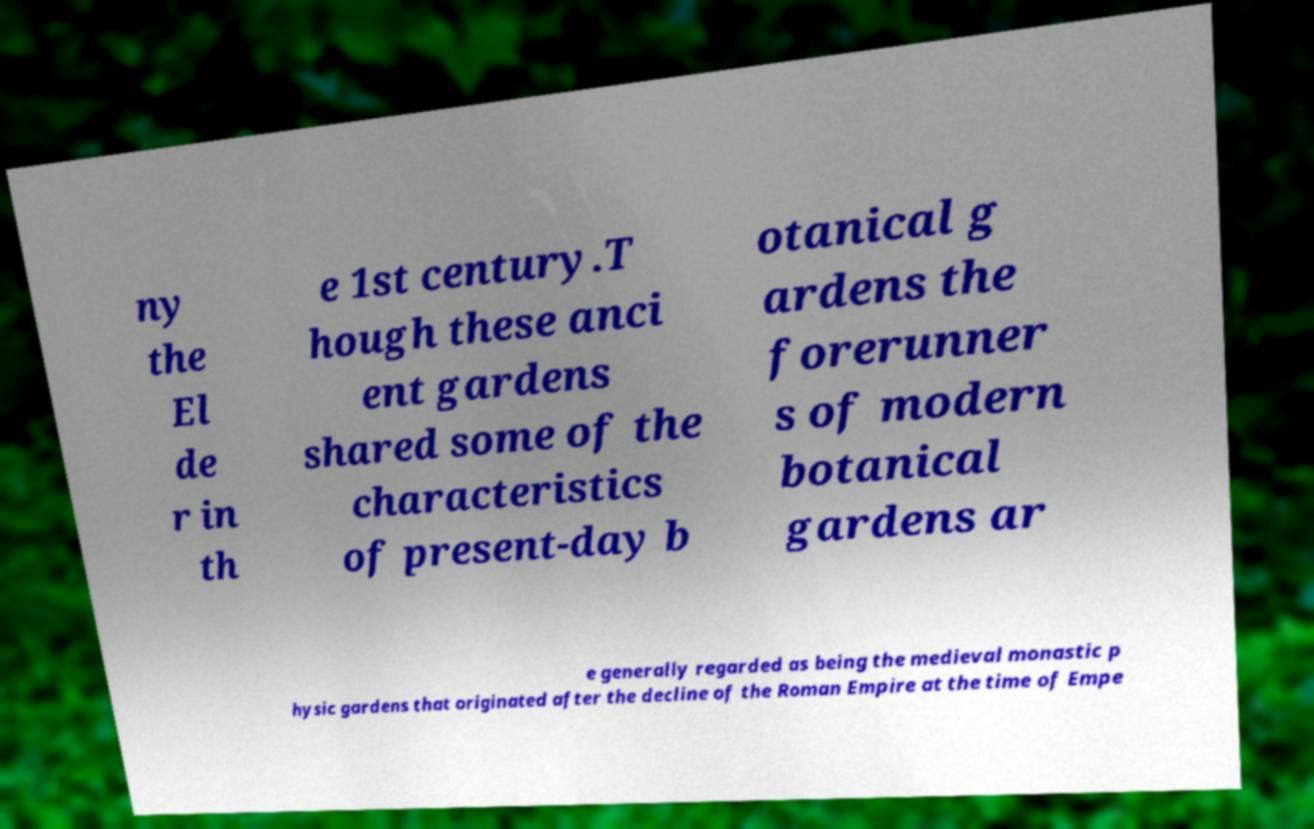For documentation purposes, I need the text within this image transcribed. Could you provide that? ny the El de r in th e 1st century.T hough these anci ent gardens shared some of the characteristics of present-day b otanical g ardens the forerunner s of modern botanical gardens ar e generally regarded as being the medieval monastic p hysic gardens that originated after the decline of the Roman Empire at the time of Empe 